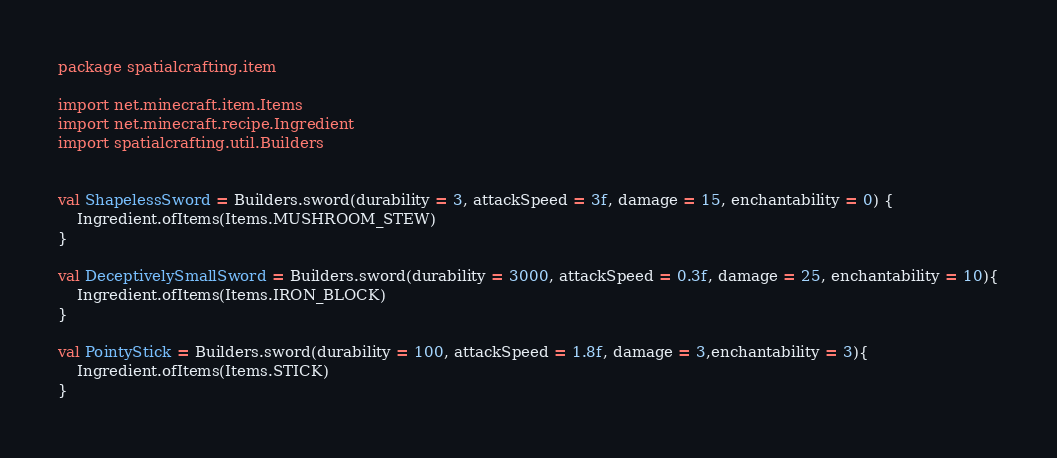<code> <loc_0><loc_0><loc_500><loc_500><_Kotlin_>package spatialcrafting.item

import net.minecraft.item.Items
import net.minecraft.recipe.Ingredient
import spatialcrafting.util.Builders


val ShapelessSword = Builders.sword(durability = 3, attackSpeed = 3f, damage = 15, enchantability = 0) {
    Ingredient.ofItems(Items.MUSHROOM_STEW)
}

val DeceptivelySmallSword = Builders.sword(durability = 3000, attackSpeed = 0.3f, damage = 25, enchantability = 10){
    Ingredient.ofItems(Items.IRON_BLOCK)
}

val PointyStick = Builders.sword(durability = 100, attackSpeed = 1.8f, damage = 3,enchantability = 3){
    Ingredient.ofItems(Items.STICK)
}</code> 